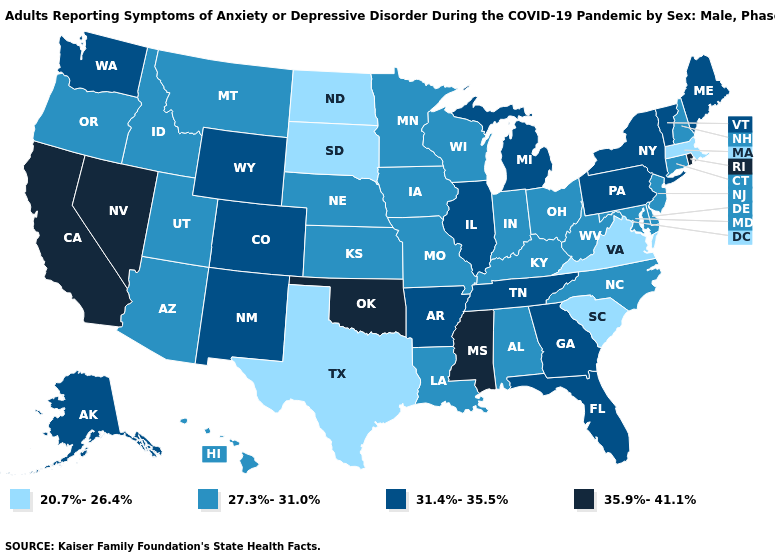Does the first symbol in the legend represent the smallest category?
Answer briefly. Yes. What is the value of Washington?
Short answer required. 31.4%-35.5%. Does South Dakota have the lowest value in the MidWest?
Write a very short answer. Yes. Does the first symbol in the legend represent the smallest category?
Give a very brief answer. Yes. What is the value of Florida?
Concise answer only. 31.4%-35.5%. What is the value of Alaska?
Quick response, please. 31.4%-35.5%. What is the value of Wisconsin?
Give a very brief answer. 27.3%-31.0%. Name the states that have a value in the range 31.4%-35.5%?
Write a very short answer. Alaska, Arkansas, Colorado, Florida, Georgia, Illinois, Maine, Michigan, New Mexico, New York, Pennsylvania, Tennessee, Vermont, Washington, Wyoming. What is the highest value in states that border Georgia?
Quick response, please. 31.4%-35.5%. How many symbols are there in the legend?
Give a very brief answer. 4. What is the value of Vermont?
Keep it brief. 31.4%-35.5%. What is the value of Maine?
Short answer required. 31.4%-35.5%. Does South Dakota have the lowest value in the USA?
Answer briefly. Yes. Does Alabama have the highest value in the USA?
Quick response, please. No. Name the states that have a value in the range 31.4%-35.5%?
Answer briefly. Alaska, Arkansas, Colorado, Florida, Georgia, Illinois, Maine, Michigan, New Mexico, New York, Pennsylvania, Tennessee, Vermont, Washington, Wyoming. 